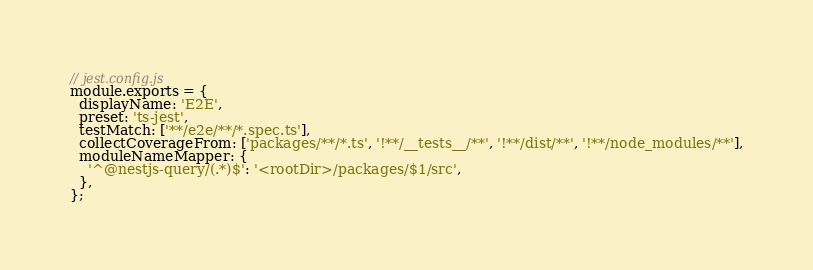Convert code to text. <code><loc_0><loc_0><loc_500><loc_500><_JavaScript_>// jest.config.js
module.exports = {
  displayName: 'E2E',
  preset: 'ts-jest',
  testMatch: ['**/e2e/**/*.spec.ts'],
  collectCoverageFrom: ['packages/**/*.ts', '!**/__tests__/**', '!**/dist/**', '!**/node_modules/**'],
  moduleNameMapper: {
    '^@nestjs-query/(.*)$': '<rootDir>/packages/$1/src',
  },
};
</code> 